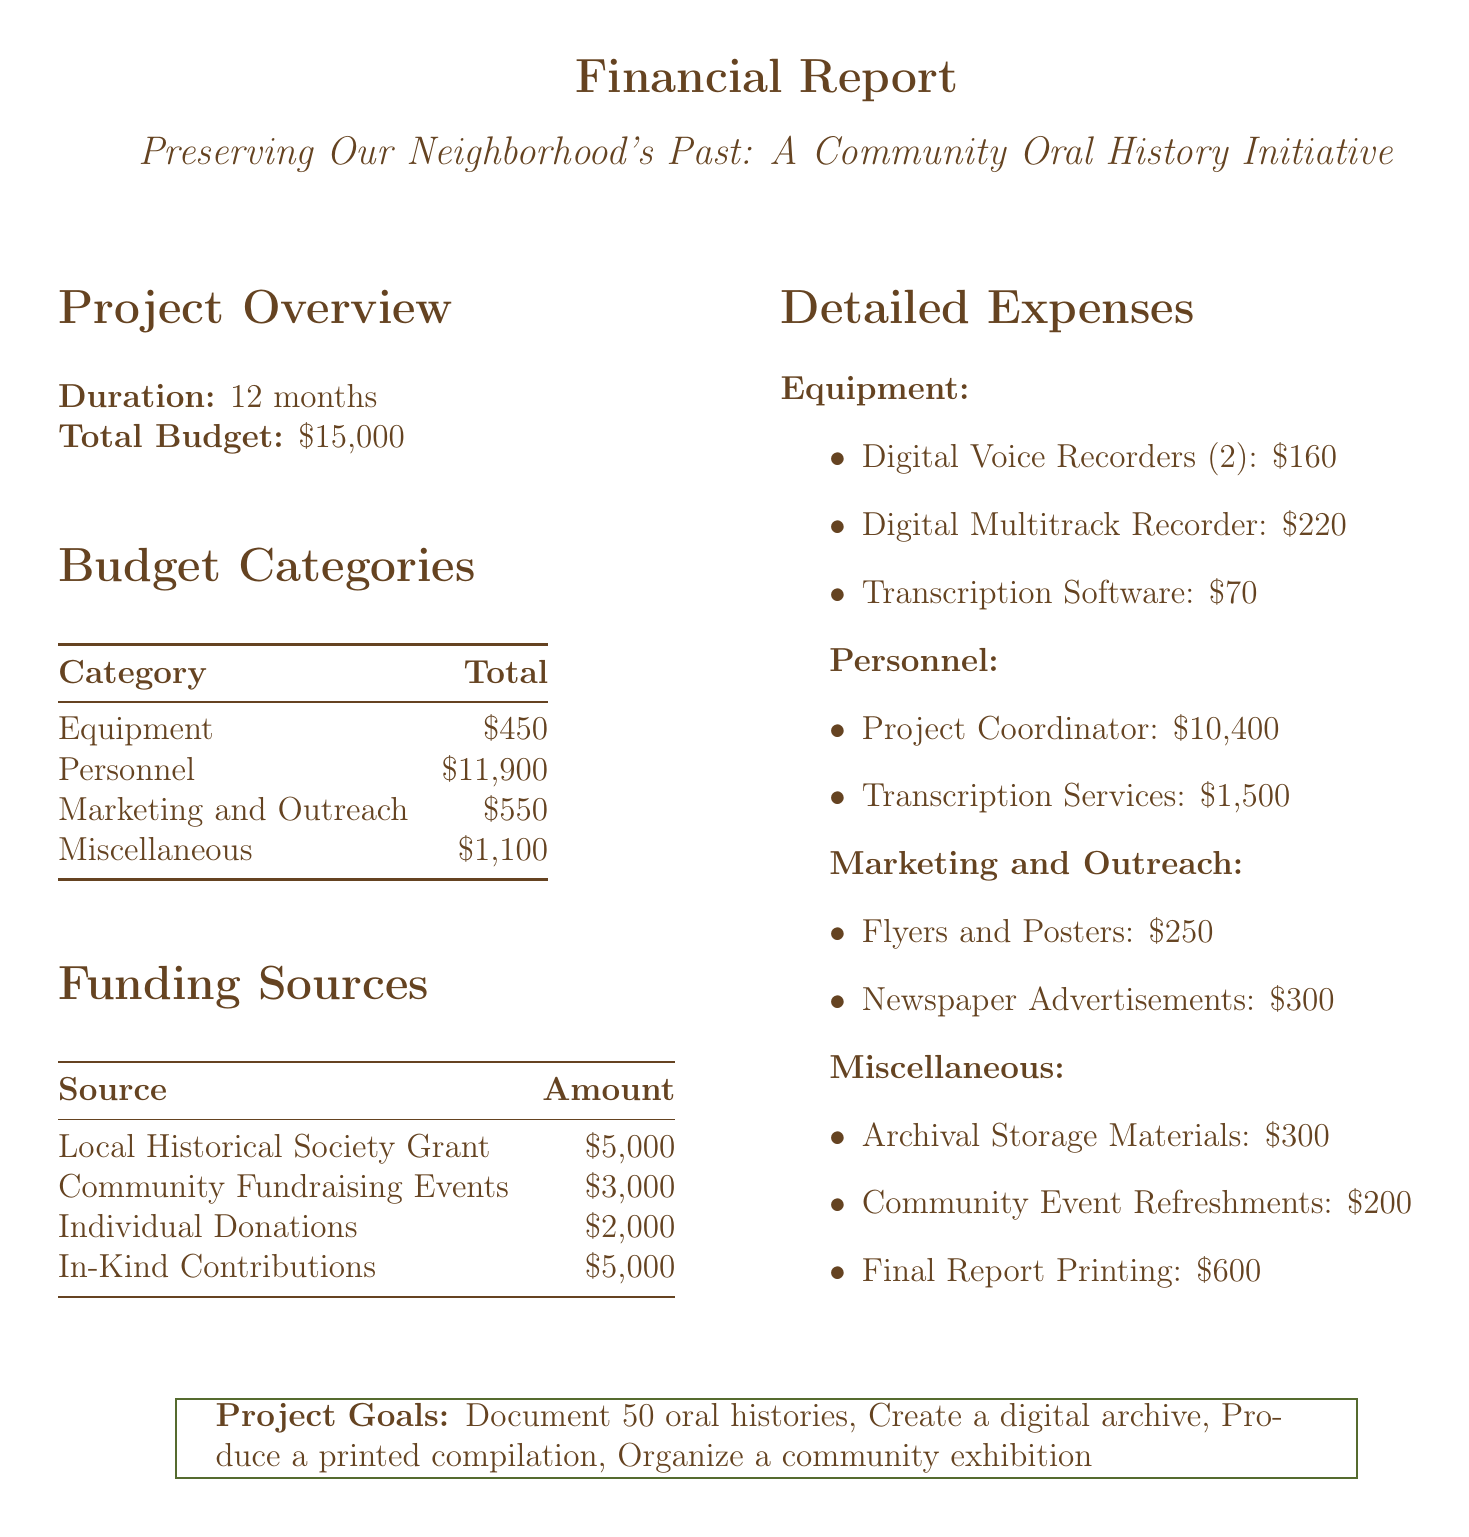what is the total budget for the project? The total budget is specified in the document under "Total Budget."
Answer: $15,000 how long is the project duration? The project duration is mentioned under "Project Overview."
Answer: 12 months how much is allocated for personnel expenses? The personnel expenses total is found in the budget categories section as "Personnel."
Answer: $11,900 which equipment item has the highest cost? The equipment items are listed with their costs, and the highest is identified under "Equipment."
Answer: Zoom H4n Pro Digital Multitrack Recorder what is the total cost for transcription services? The cost of transcription services is included in the detailed expenses under personnel.
Answer: $1,500 how much funding is expected from individual donations? The amount from individual donations is specified in the funding sources table.
Answer: $2,000 what is one of the project goals? The project goals list several aims, including documentation of histories.
Answer: Document 50 oral histories how many flyers and posters will be printed? The number of flyers and posters is listed under marketing and outreach expenses.
Answer: 500 what are the total expenses for marketing and outreach? The marketing and outreach expenses total can be found in the budget categories.
Answer: $550 